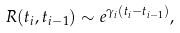Convert formula to latex. <formula><loc_0><loc_0><loc_500><loc_500>R ( t _ { i } , t _ { i - 1 } ) \sim e ^ { \gamma _ { i } ( t _ { i } - t _ { i - 1 } ) } ,</formula> 